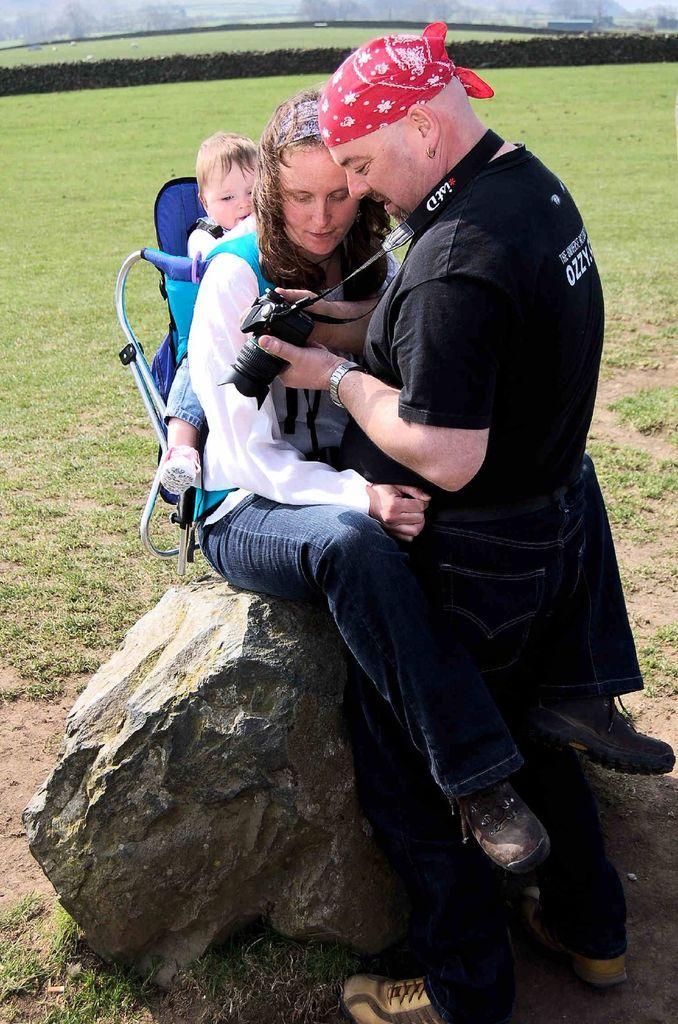Can you describe this image briefly? In this image we can see a man, woman and boy. Man is wearing black color dress with jeans and holding camera. Woman is wearing white color shirt with jeans and carrying baby on her back. She is sitting on rock. Background of the image grassy land is there. 